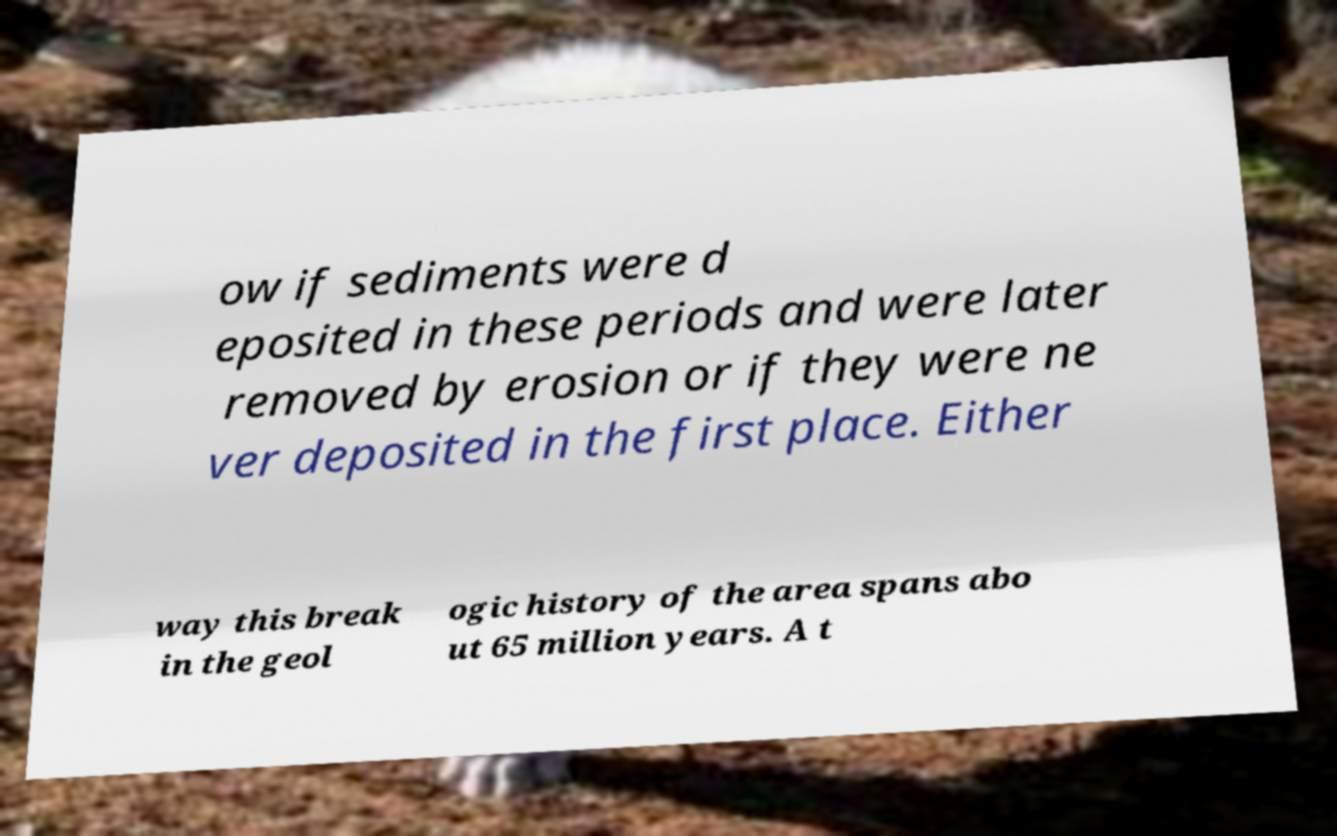Could you assist in decoding the text presented in this image and type it out clearly? ow if sediments were d eposited in these periods and were later removed by erosion or if they were ne ver deposited in the first place. Either way this break in the geol ogic history of the area spans abo ut 65 million years. A t 